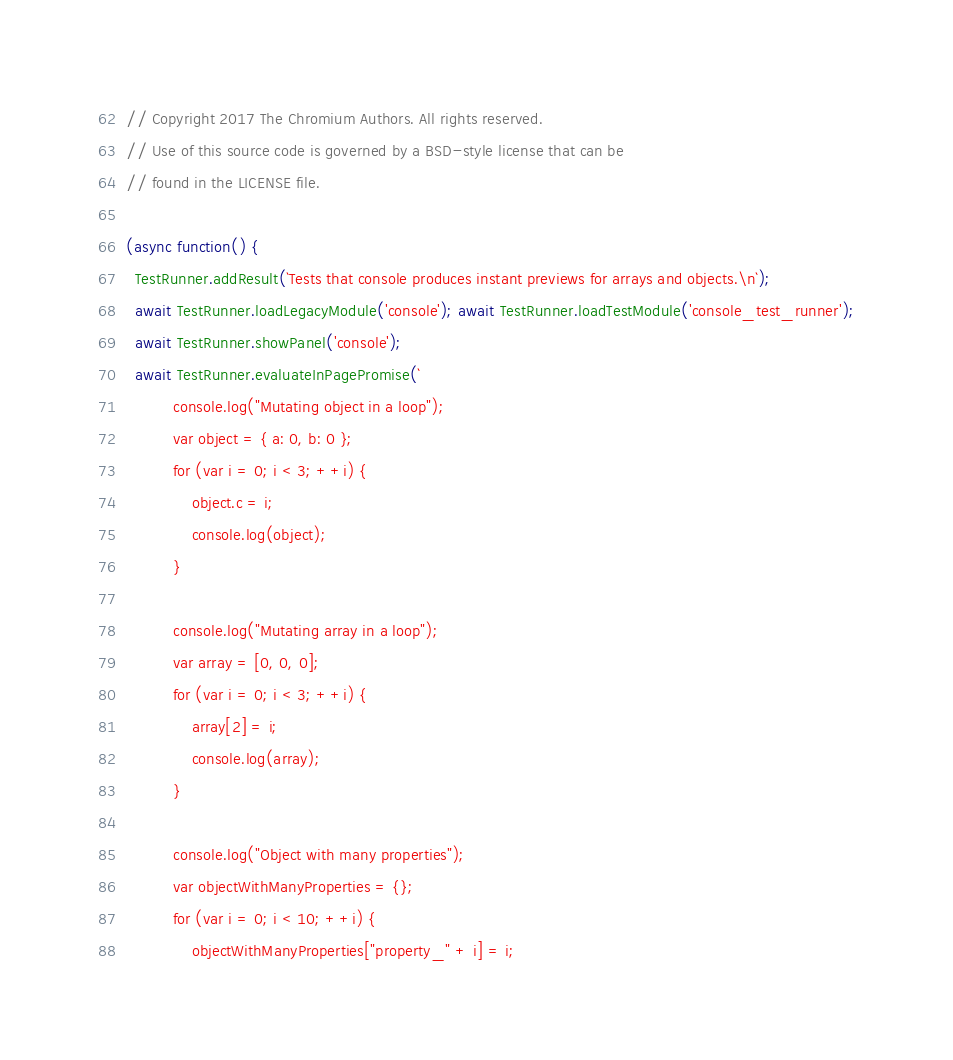<code> <loc_0><loc_0><loc_500><loc_500><_JavaScript_>// Copyright 2017 The Chromium Authors. All rights reserved.
// Use of this source code is governed by a BSD-style license that can be
// found in the LICENSE file.

(async function() {
  TestRunner.addResult(`Tests that console produces instant previews for arrays and objects.\n`);
  await TestRunner.loadLegacyModule('console'); await TestRunner.loadTestModule('console_test_runner');
  await TestRunner.showPanel('console');
  await TestRunner.evaluateInPagePromise(`
          console.log("Mutating object in a loop");
          var object = { a: 0, b: 0 };
          for (var i = 0; i < 3; ++i) {
              object.c = i;
              console.log(object);
          }

          console.log("Mutating array in a loop");
          var array = [0, 0, 0];
          for (var i = 0; i < 3; ++i) {
              array[2] = i;
              console.log(array);
          }

          console.log("Object with many properties");
          var objectWithManyProperties = {};
          for (var i = 0; i < 10; ++i) {
              objectWithManyProperties["property_" + i] = i;</code> 